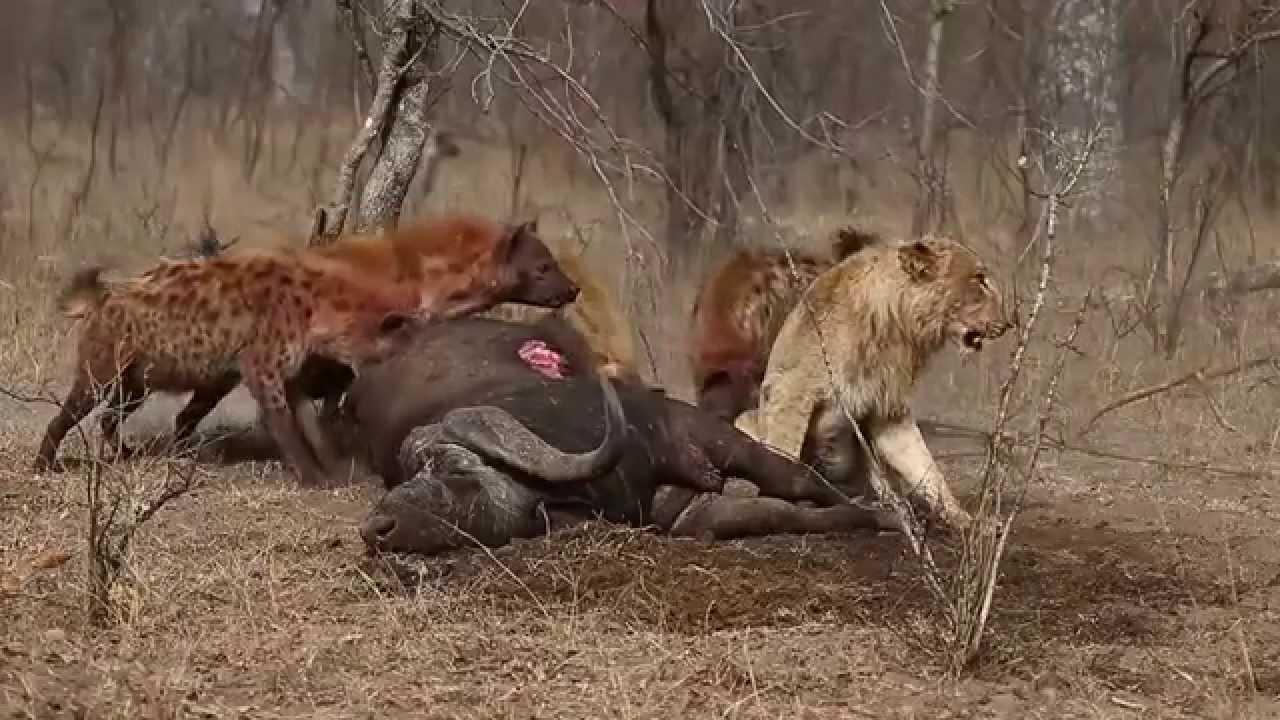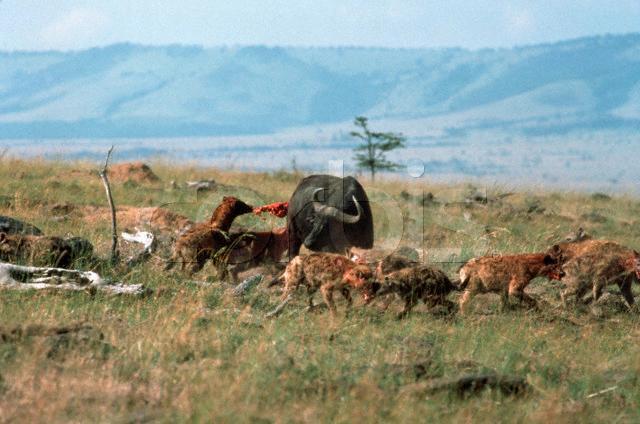The first image is the image on the left, the second image is the image on the right. Given the left and right images, does the statement "Hyenas are circling their prey, which is still up on all 4 legs in both images." hold true? Answer yes or no. No. The first image is the image on the left, the second image is the image on the right. For the images shown, is this caption "an animal is being eaten on the left pic" true? Answer yes or no. Yes. 